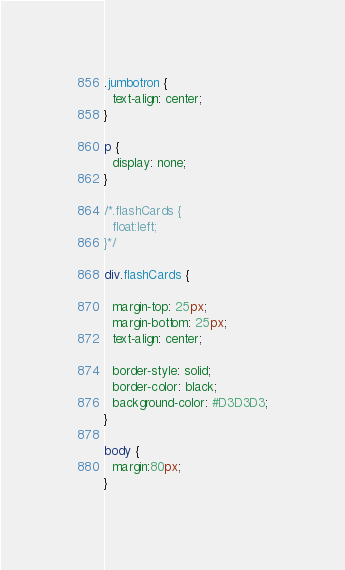Convert code to text. <code><loc_0><loc_0><loc_500><loc_500><_CSS_>.jumbotron {
  text-align: center;
}

p {
  display: none;
}

/*.flashCards {
  float:left;
}*/

div.flashCards {

  margin-top: 25px;
  margin-bottom: 25px;
  text-align: center;

  border-style: solid;
  border-color: black;
  background-color: #D3D3D3;
}

body {
  margin:80px;
}
</code> 